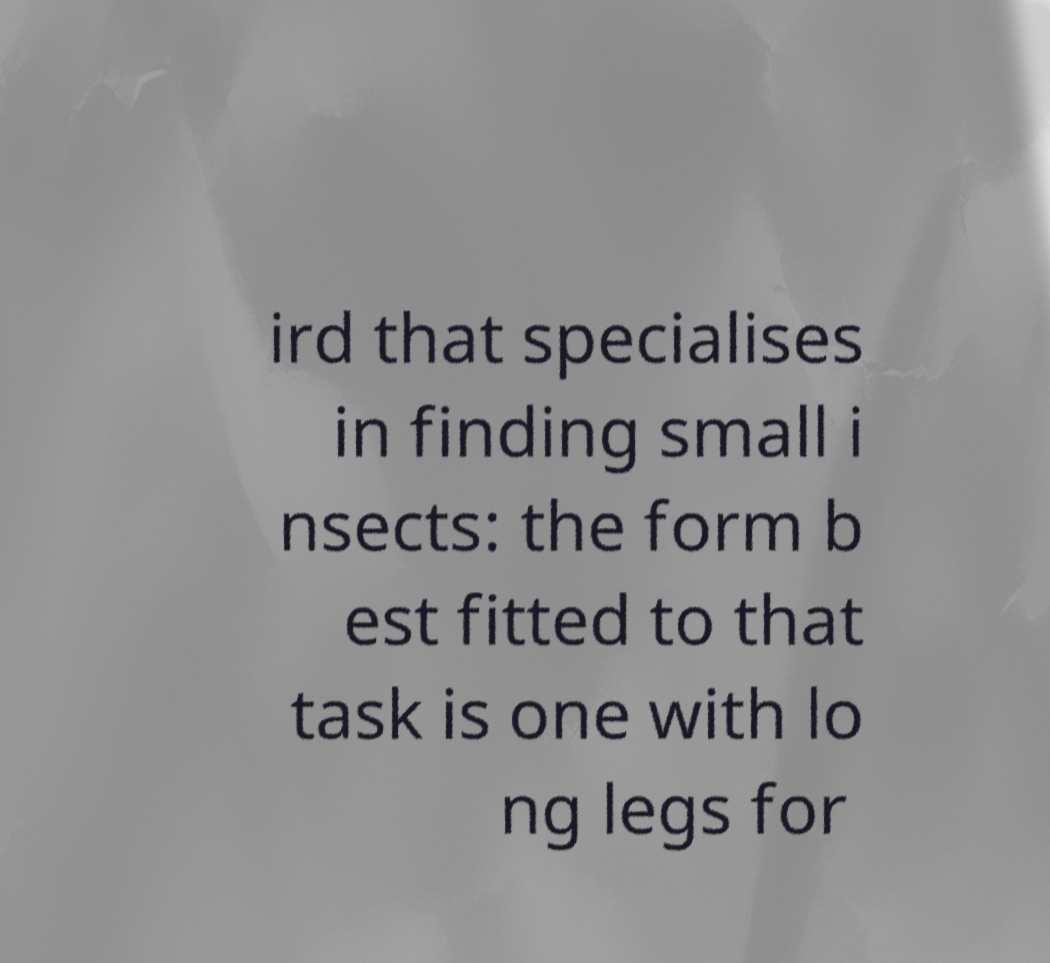There's text embedded in this image that I need extracted. Can you transcribe it verbatim? ird that specialises in finding small i nsects: the form b est fitted to that task is one with lo ng legs for 